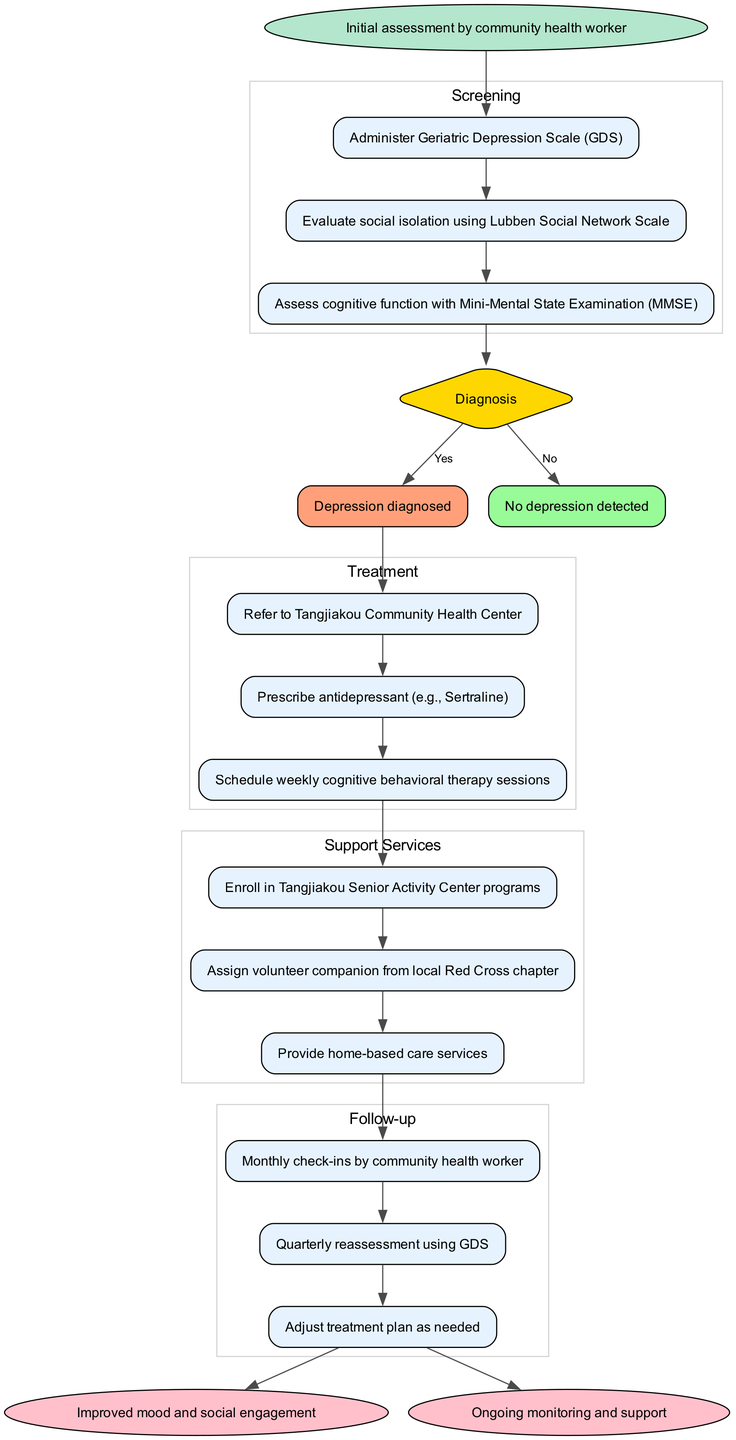what is the starting point of the clinical pathway? The starting point is indicated as "Initial assessment by community health worker," which is the first node in the diagram.
Answer: Initial assessment by community health worker how many screening steps are listed in the diagram? There are three screening steps listed: administering the Geriatric Depression Scale, evaluating social isolation, and assessing cognitive function. Counting these gives a total of three.
Answer: 3 what is the diagnosis if the screening shows positive results? The diagnosis node connected to the positive outcomes states "Depression diagnosed." This indicates the outcome if the screening is positive.
Answer: Depression diagnosed what follows after the examination step if depression is diagnosed? If depression is diagnosed, the next steps involve treatments, starting with a referral to the Tangjiakou Community Health Center, as indicated in the flow from the diagnosis node to the treatment steps.
Answer: Refer to Tangjiakou Community Health Center which support service is related to volunteering? The service listed that pertains to volunteering is "Assign volunteer companion from local Red Cross chapter," which is specifically focused on providing companionship through volunteers.
Answer: Assign volunteer companion from local Red Cross chapter what is the first follow-up action after support services? The first follow-up action after support services is "Monthly check-ins by community health worker," which shows the continuity of care following the support phase.
Answer: Monthly check-ins by community health worker how are the treatment steps connected to the diagnosis? The treatment steps are connected to the diagnosis by an edge starting from the positive diagnosis node, indicating that the treatment steps follow only if the diagnosis is positive.
Answer: By a directed edge from positive diagnosis node what is the end goal of the pathway? The end goals of the pathway are to achieve either "Improved mood and social engagement" or "Ongoing monitoring and support," which are the terminal points in the flow diagram.
Answer: Improved mood and social engagement; Ongoing monitoring and support 